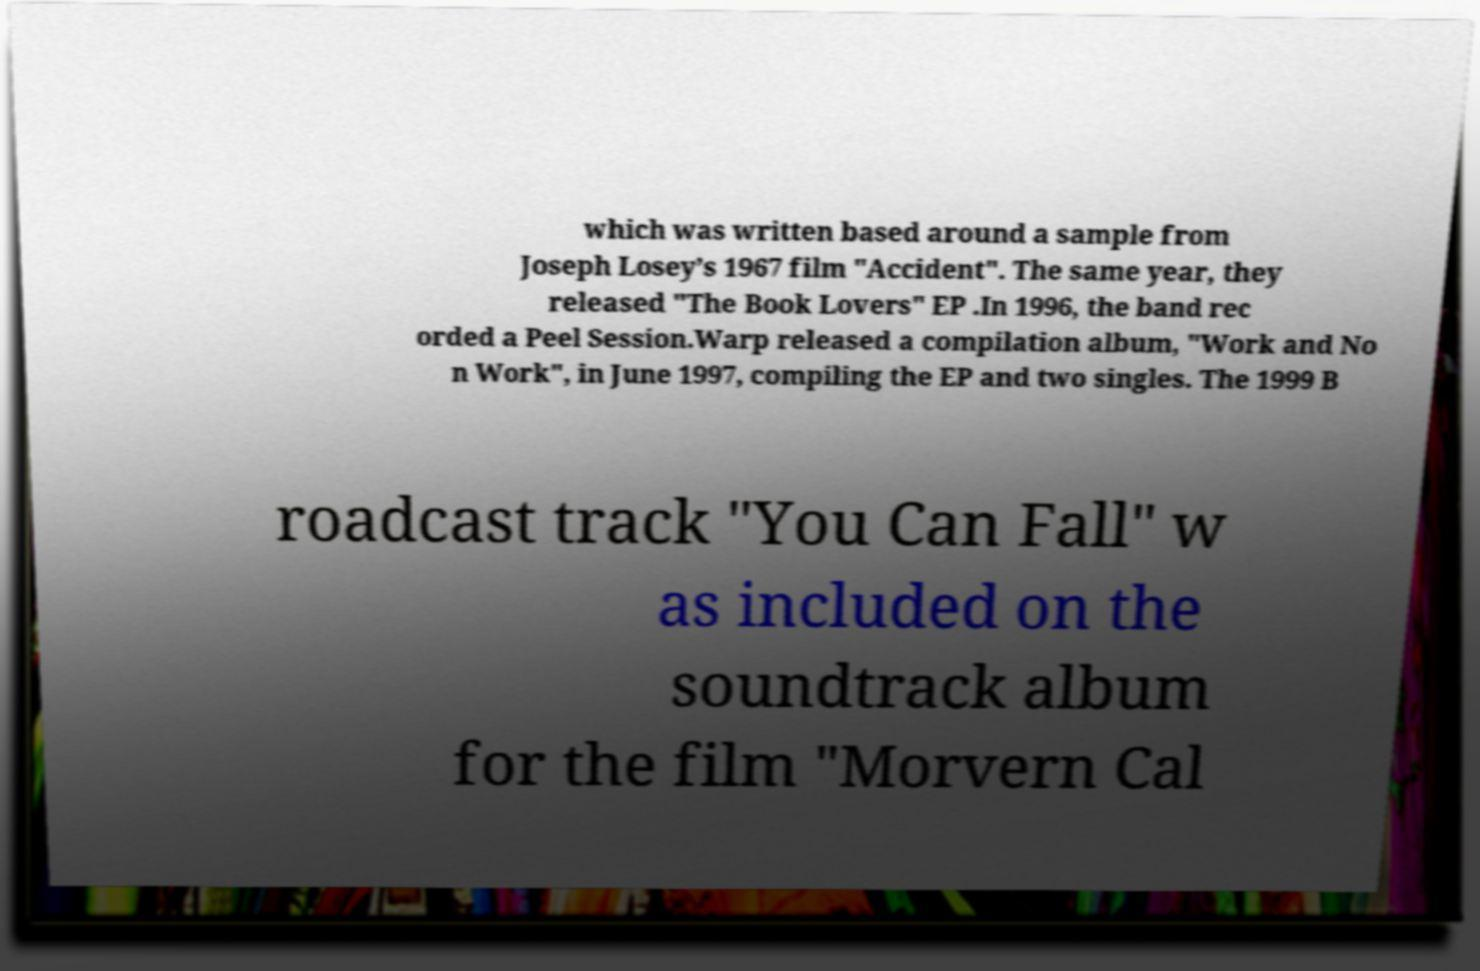Could you assist in decoding the text presented in this image and type it out clearly? which was written based around a sample from Joseph Losey’s 1967 film "Accident". The same year, they released "The Book Lovers" EP .In 1996, the band rec orded a Peel Session.Warp released a compilation album, "Work and No n Work", in June 1997, compiling the EP and two singles. The 1999 B roadcast track "You Can Fall" w as included on the soundtrack album for the film "Morvern Cal 